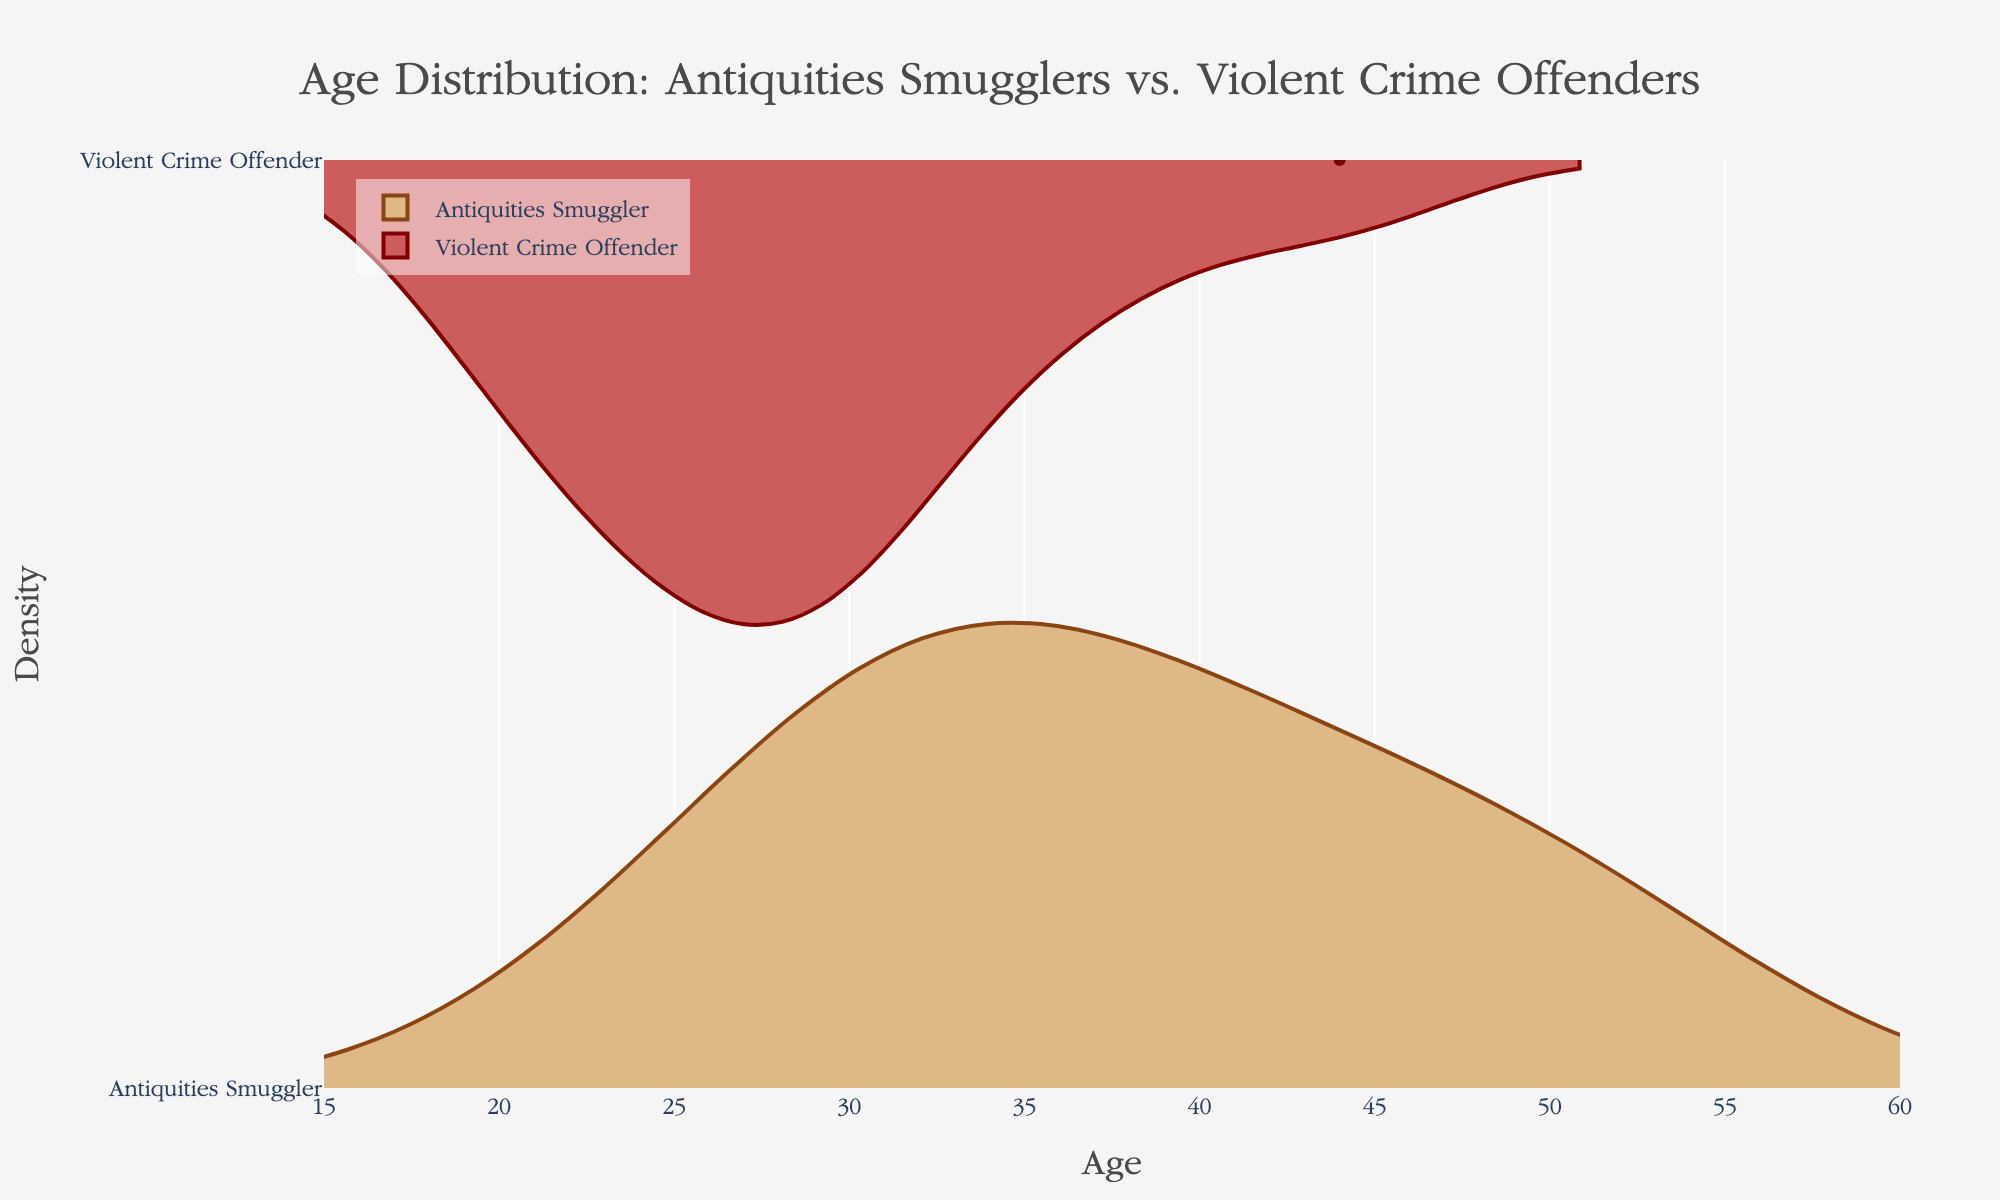What do the colors of each violin plot represent? The colors of the violin plots signify different criminal types. The brown color represents antiquities smugglers, while the deep red color represents violent crime offenders.
Answer: Different criminal types What is the title of the figure? The title is located at the top of the figure and reads "Age Distribution: Antiquities Smugglers vs. Violent Crime Offenders", indicating the comparison of age distributions between the two groups.
Answer: Age Distribution: Antiquities Smugglers vs. Violent Crime Offenders What does the x-axis represent in the figure? The x-axis represents the ages of the individuals within each criminal group. This helps us compare the age distributions between antiquities smugglers and violent crime offenders.
Answer: Age Which criminal type has a younger average age, based on the figure? By visually comparing the density and spread of the violins, violent crime offenders appear younger on average as their distribution is more concentrated in the lower age range compared to antiquities smugglers.
Answer: Violent Crime Offenders What is the approximate age range observed for antiquities smugglers? The age range can be identified by looking at the spread of the positive side of the violin plot for antiquities smugglers, which ranges approximately from 23 to 54.
Answer: 23 to 54 Which group has a more diverse age range? By comparing the width and spread of the violins, antiquities smugglers have a more diverse age range as their distribution is wider and covers more age groups compared to violent crime offenders.
Answer: Antiquities Smugglers Are the age distributions for both groups symmetrical? Symmetry in the violin plots can be observed if the density is evenly spread on both sides. The positive and negative sides show some asymmetry, indicating differing age distributions within each group.
Answer: No What is the most common age range for violent crime offenders? The most common age range can be seen where the density of the violin is thickest. For violent crime offenders, this appears to be between 19 and 30 years old.
Answer: 19 to 30 What is the age of the oldest recorded antiquities smuggler? The oldest recorded age can be identified from the furthest point on the positive side of the violin plot for antiquities smugglers, which is 54 years.
Answer: 54 How do the highest-density areas for each group compare? Comparing the areas where the violins are the thickest, violent crime offenders have a higher density of younger individuals, while antiquities smugglers show a wider spread with less density but tend towards an older average age.
Answer: Higher density of younger individuals for violent crime offenders; wider spread for older for antiquities smugglers 